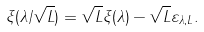Convert formula to latex. <formula><loc_0><loc_0><loc_500><loc_500>\xi ( \lambda / \sqrt { L } ) = \sqrt { L } \xi ( \lambda ) - \sqrt { L } \varepsilon _ { \lambda , L } .</formula> 